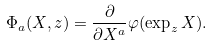<formula> <loc_0><loc_0><loc_500><loc_500>\Phi _ { a } ( X , z ) = \frac { \partial } { \partial X ^ { a } } \varphi ( \exp _ { z } X ) .</formula> 